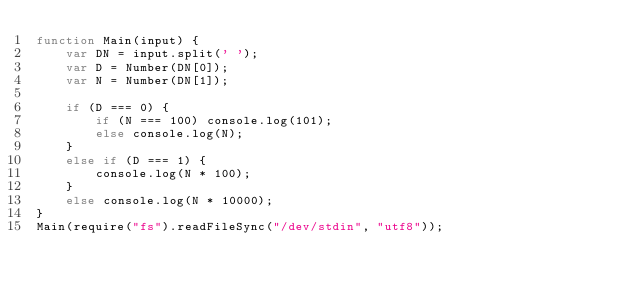<code> <loc_0><loc_0><loc_500><loc_500><_JavaScript_>function Main(input) {
    var DN = input.split(' ');
    var D = Number(DN[0]);
    var N = Number(DN[1]);

    if (D === 0) {
        if (N === 100) console.log(101);
        else console.log(N);
    }
    else if (D === 1) {
        console.log(N * 100);
    }
    else console.log(N * 10000);    
}
Main(require("fs").readFileSync("/dev/stdin", "utf8"));
</code> 